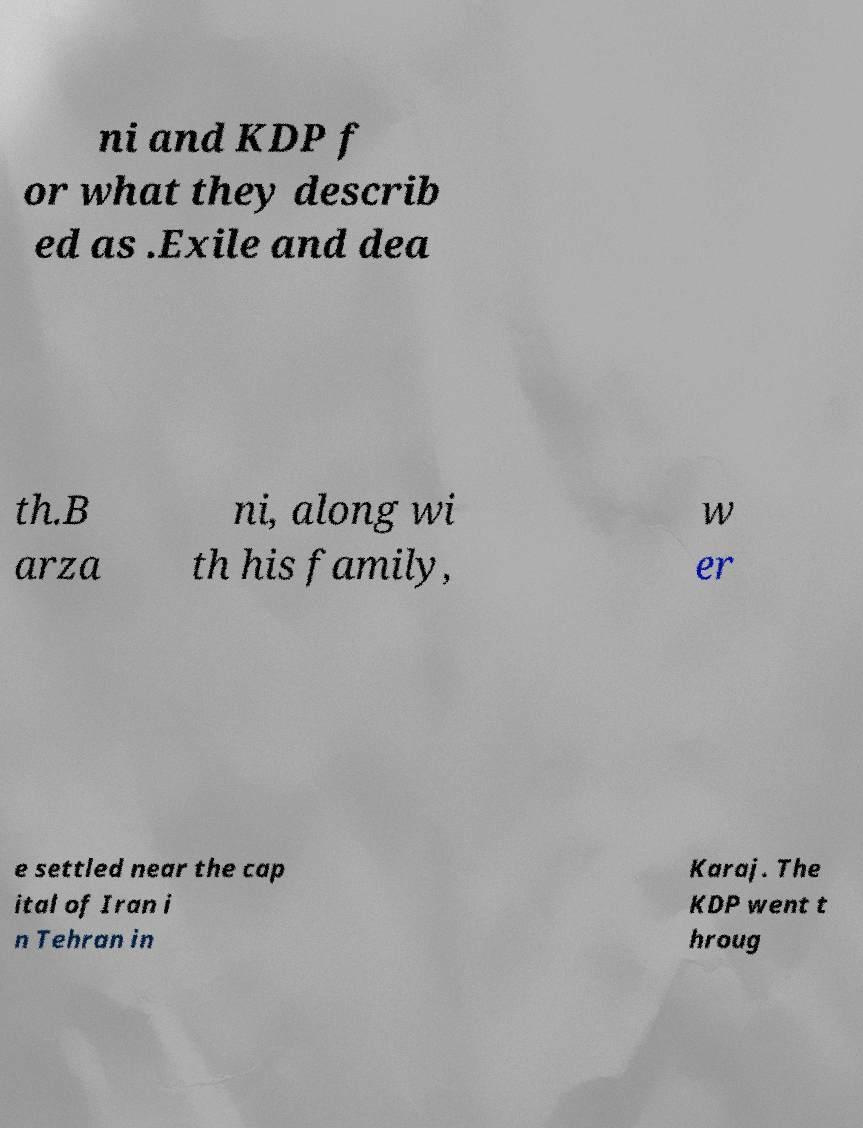Please read and relay the text visible in this image. What does it say? ni and KDP f or what they describ ed as .Exile and dea th.B arza ni, along wi th his family, w er e settled near the cap ital of Iran i n Tehran in Karaj. The KDP went t hroug 